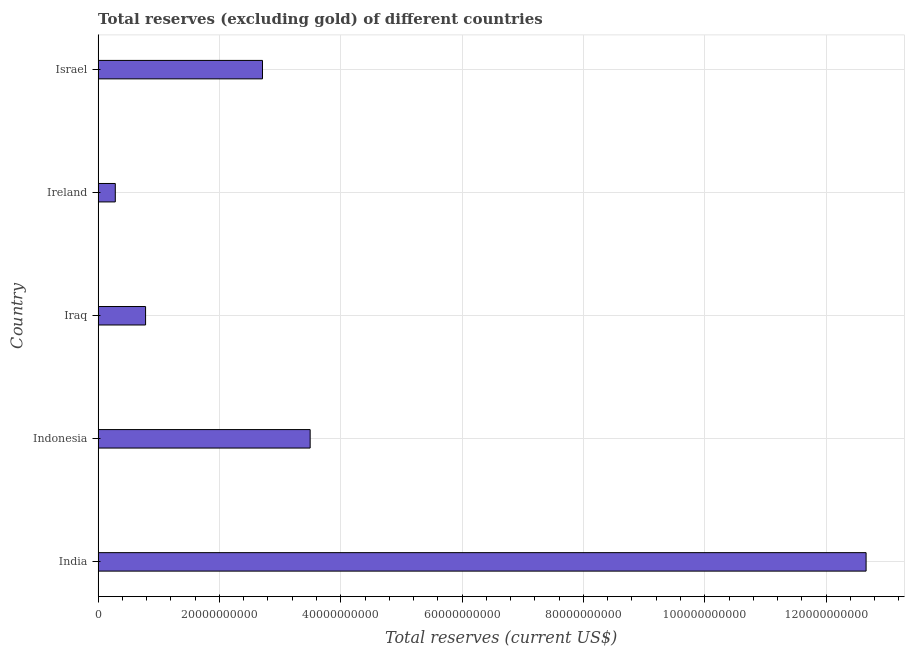What is the title of the graph?
Make the answer very short. Total reserves (excluding gold) of different countries. What is the label or title of the X-axis?
Provide a short and direct response. Total reserves (current US$). What is the label or title of the Y-axis?
Provide a short and direct response. Country. What is the total reserves (excluding gold) in Ireland?
Keep it short and to the point. 2.83e+09. Across all countries, what is the maximum total reserves (excluding gold)?
Your answer should be compact. 1.27e+11. Across all countries, what is the minimum total reserves (excluding gold)?
Make the answer very short. 2.83e+09. In which country was the total reserves (excluding gold) maximum?
Keep it short and to the point. India. In which country was the total reserves (excluding gold) minimum?
Make the answer very short. Ireland. What is the sum of the total reserves (excluding gold)?
Make the answer very short. 1.99e+11. What is the difference between the total reserves (excluding gold) in India and Indonesia?
Your answer should be very brief. 9.16e+1. What is the average total reserves (excluding gold) per country?
Make the answer very short. 3.99e+1. What is the median total reserves (excluding gold)?
Your response must be concise. 2.71e+1. What is the ratio of the total reserves (excluding gold) in Iraq to that in Israel?
Give a very brief answer. 0.29. What is the difference between the highest and the second highest total reserves (excluding gold)?
Provide a succinct answer. 9.16e+1. What is the difference between the highest and the lowest total reserves (excluding gold)?
Your response must be concise. 1.24e+11. In how many countries, is the total reserves (excluding gold) greater than the average total reserves (excluding gold) taken over all countries?
Give a very brief answer. 1. How many bars are there?
Offer a terse response. 5. How many countries are there in the graph?
Keep it short and to the point. 5. What is the difference between two consecutive major ticks on the X-axis?
Provide a succinct answer. 2.00e+1. What is the Total reserves (current US$) of India?
Give a very brief answer. 1.27e+11. What is the Total reserves (current US$) in Indonesia?
Provide a succinct answer. 3.50e+1. What is the Total reserves (current US$) of Iraq?
Provide a succinct answer. 7.82e+09. What is the Total reserves (current US$) in Ireland?
Your answer should be very brief. 2.83e+09. What is the Total reserves (current US$) of Israel?
Keep it short and to the point. 2.71e+1. What is the difference between the Total reserves (current US$) in India and Indonesia?
Your answer should be compact. 9.16e+1. What is the difference between the Total reserves (current US$) in India and Iraq?
Ensure brevity in your answer.  1.19e+11. What is the difference between the Total reserves (current US$) in India and Ireland?
Your answer should be very brief. 1.24e+11. What is the difference between the Total reserves (current US$) in India and Israel?
Your answer should be compact. 9.95e+1. What is the difference between the Total reserves (current US$) in Indonesia and Iraq?
Provide a succinct answer. 2.71e+1. What is the difference between the Total reserves (current US$) in Indonesia and Ireland?
Ensure brevity in your answer.  3.21e+1. What is the difference between the Total reserves (current US$) in Indonesia and Israel?
Provide a short and direct response. 7.86e+09. What is the difference between the Total reserves (current US$) in Iraq and Ireland?
Provide a succinct answer. 4.99e+09. What is the difference between the Total reserves (current US$) in Iraq and Israel?
Offer a very short reply. -1.93e+1. What is the difference between the Total reserves (current US$) in Ireland and Israel?
Provide a succinct answer. -2.43e+1. What is the ratio of the Total reserves (current US$) in India to that in Indonesia?
Provide a short and direct response. 3.62. What is the ratio of the Total reserves (current US$) in India to that in Iraq?
Your response must be concise. 16.18. What is the ratio of the Total reserves (current US$) in India to that in Ireland?
Your answer should be compact. 44.72. What is the ratio of the Total reserves (current US$) in India to that in Israel?
Offer a very short reply. 4.67. What is the ratio of the Total reserves (current US$) in Indonesia to that in Iraq?
Provide a short and direct response. 4.47. What is the ratio of the Total reserves (current US$) in Indonesia to that in Ireland?
Your answer should be compact. 12.35. What is the ratio of the Total reserves (current US$) in Indonesia to that in Israel?
Ensure brevity in your answer.  1.29. What is the ratio of the Total reserves (current US$) in Iraq to that in Ireland?
Offer a very short reply. 2.76. What is the ratio of the Total reserves (current US$) in Iraq to that in Israel?
Make the answer very short. 0.29. What is the ratio of the Total reserves (current US$) in Ireland to that in Israel?
Make the answer very short. 0.1. 